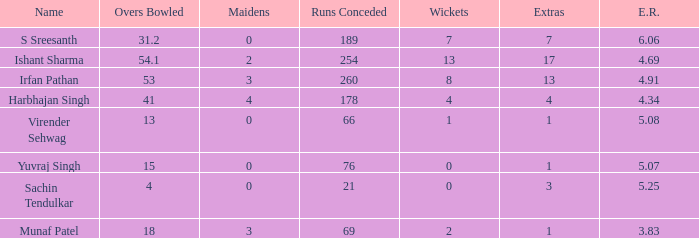Identify the wickets for 15 overs bowled. 0.0. 